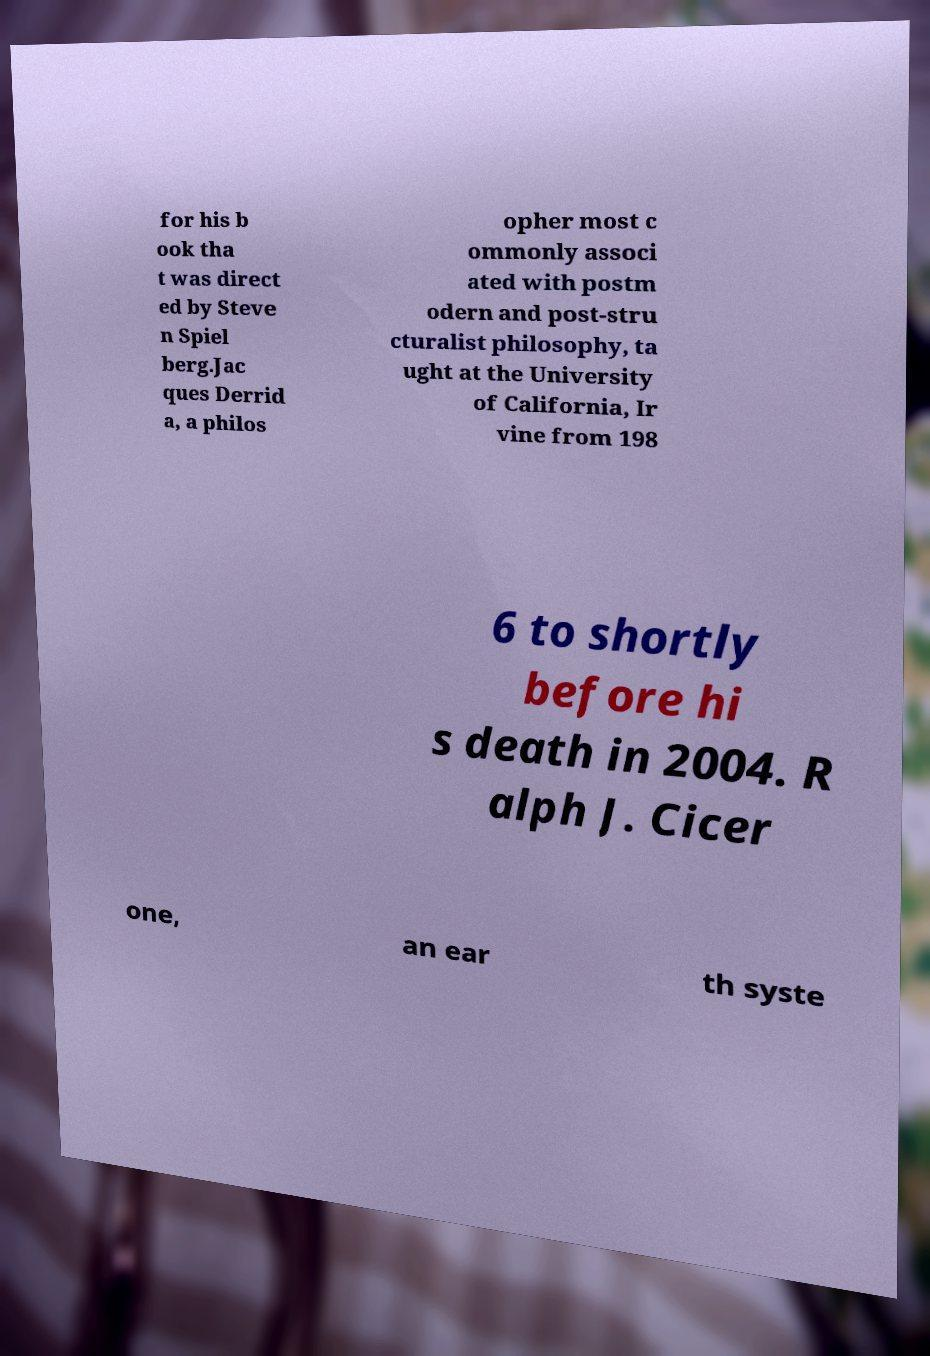Can you read and provide the text displayed in the image?This photo seems to have some interesting text. Can you extract and type it out for me? for his b ook tha t was direct ed by Steve n Spiel berg.Jac ques Derrid a, a philos opher most c ommonly associ ated with postm odern and post-stru cturalist philosophy, ta ught at the University of California, Ir vine from 198 6 to shortly before hi s death in 2004. R alph J. Cicer one, an ear th syste 